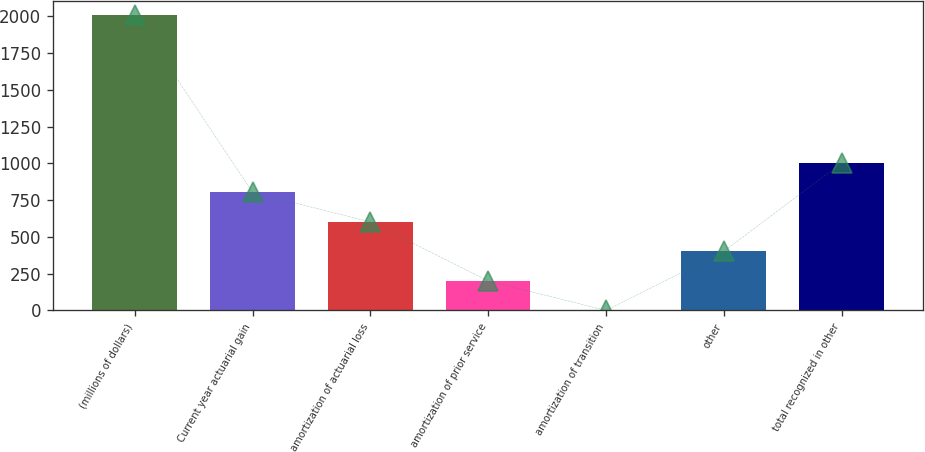Convert chart to OTSL. <chart><loc_0><loc_0><loc_500><loc_500><bar_chart><fcel>(millions of dollars)<fcel>Current year actuarial gain<fcel>amortization of actuarial loss<fcel>amortization of prior service<fcel>amortization of transition<fcel>other<fcel>total recognized in other<nl><fcel>2007<fcel>802.86<fcel>602.17<fcel>200.79<fcel>0.1<fcel>401.48<fcel>1003.55<nl></chart> 